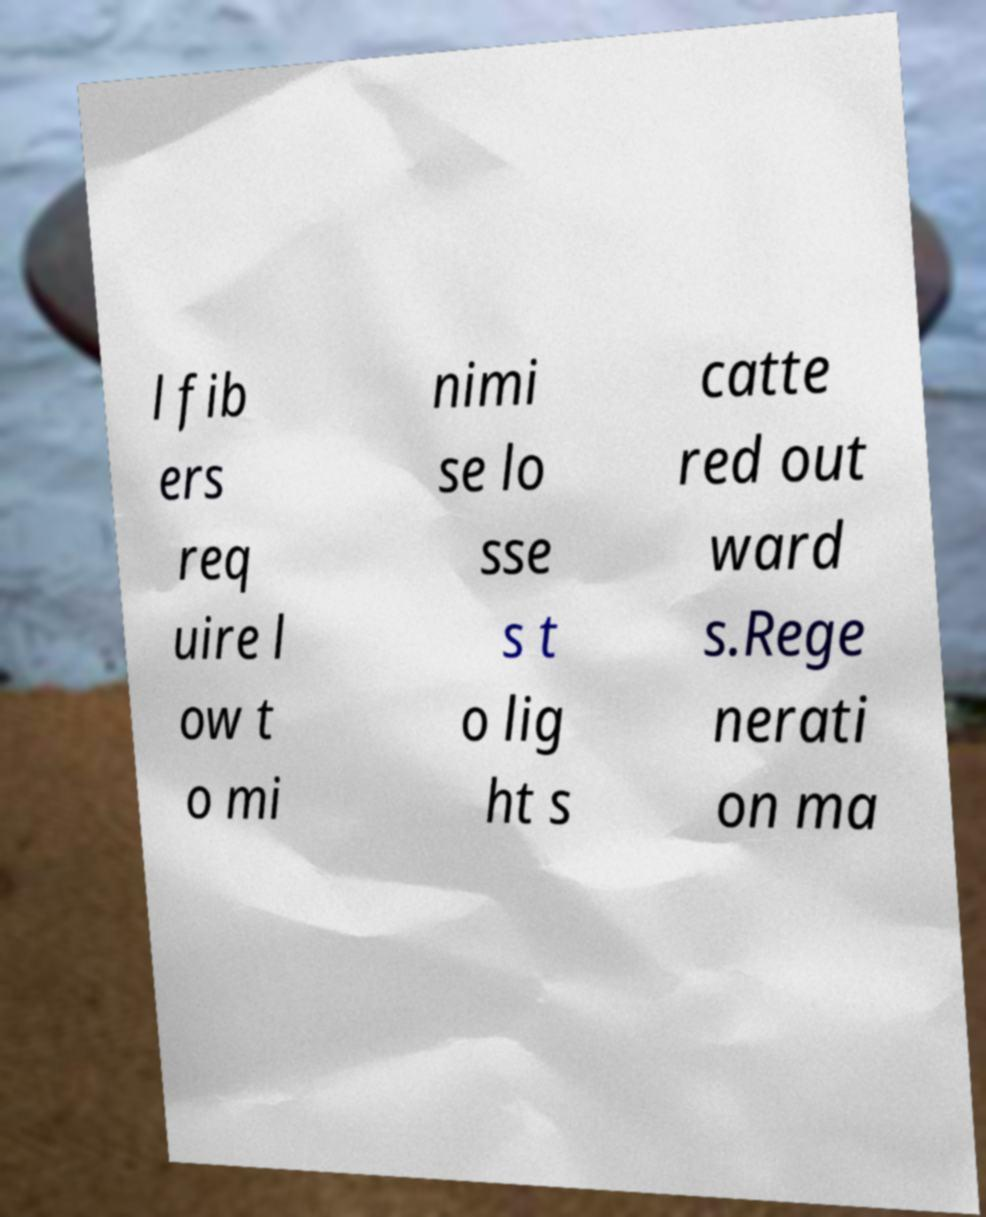Can you read and provide the text displayed in the image?This photo seems to have some interesting text. Can you extract and type it out for me? l fib ers req uire l ow t o mi nimi se lo sse s t o lig ht s catte red out ward s.Rege nerati on ma 